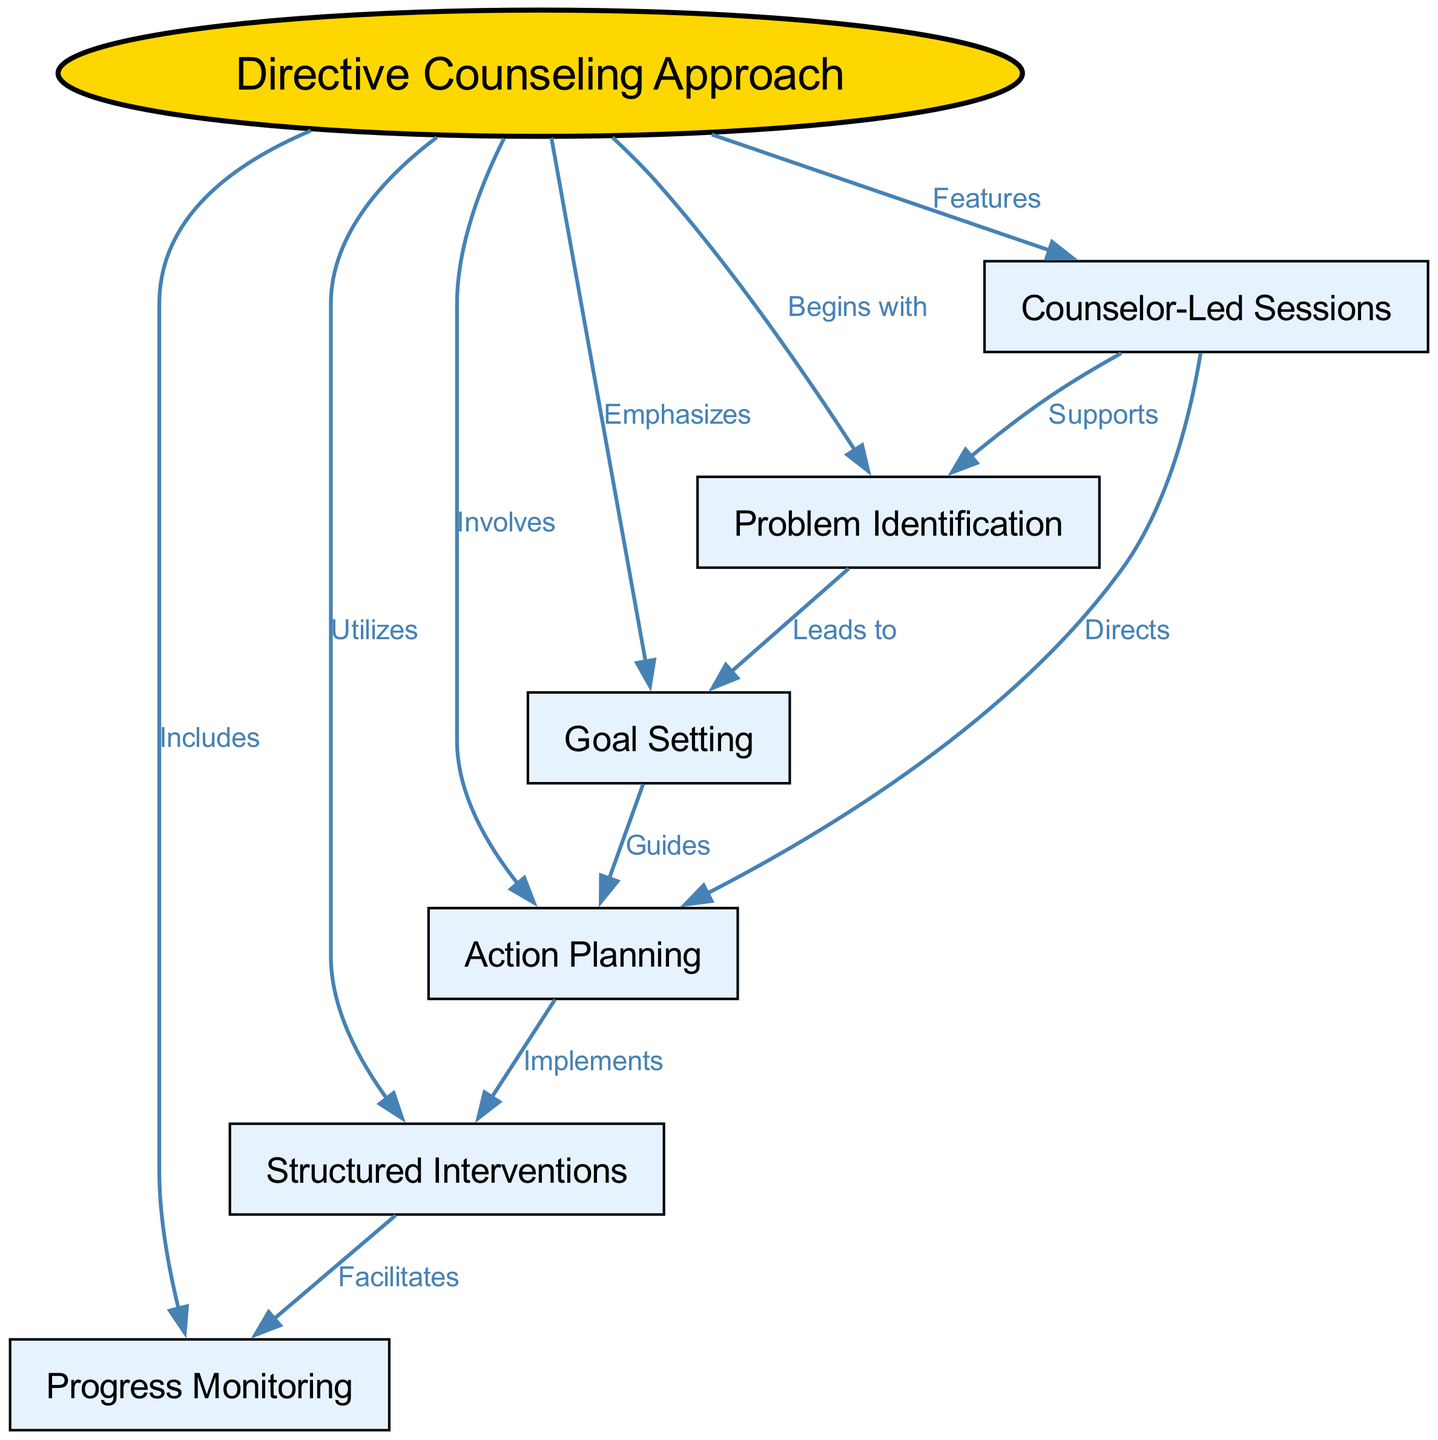What is the central concept of the diagram? The central concept of the diagram is represented by the first node, labeled "Directive Counseling Approach." This node is featured prominently at the top of the diagram, indicating it is the main focus.
Answer: Directive Counseling Approach How many nodes are present in the diagram? By counting the listed nodes in the JSON structure, we find there are 7 nodes total: "Directive Counseling Approach," "Goal Setting," "Problem Identification," "Action Planning," "Structured Interventions," "Progress Monitoring," and "Counselor-Led Sessions."
Answer: 7 What relationship does "Problem Identification" have with "Goal Setting"? Examining the edges that connect the nodes, we see that there is a directed edge indicating "Problem Identification" leads to "Goal Setting." This implies that identifying problems plays a crucial role in setting goals.
Answer: Leads to Which component involves implementing structured interventions? Looking at the connections in the diagram, "Action Planning" has a directed edge to "Structured Interventions" labeled "Implements," indicating that the action planning phase is where these interventions are put into practice.
Answer: Action Planning What does "Progress Monitoring" include? The edge from "Directive Counseling Approach" to "Progress Monitoring" is labeled "Includes," which indicates that progress monitoring is an integral part of the directive counseling approach. This means that tracking progress is a necessary component of this methodology.
Answer: Includes How does "Counselor-Led Sessions" support the planning process? The diagram shows a directed edge from "Counselor-Led Sessions" to "Problem Identification" labeled "Supports," indicating that counselor-led sessions facilitate an understanding of issues, which is essential for proper planning. Therefore, these sessions help in identifying problems as a precursor to effective planning.
Answer: Supports What is the role of "Goal Setting" in this approach? The edge connecting "Problem Identification" to "Goal Setting" indicates that identifying issues is a step that leads specifically to the process of setting goals, which gives structure to the counseling process. Thus, its role is foundational in the counseling approach.
Answer: Guides Which component is highlighted as emphasizing specific actions? The relationship between the "Directive Counseling Approach" and "Goal Setting," indicated by the label "Emphasizes," indicates that the approach places significant importance on setting clear and actionable goals.
Answer: Emphasizes 